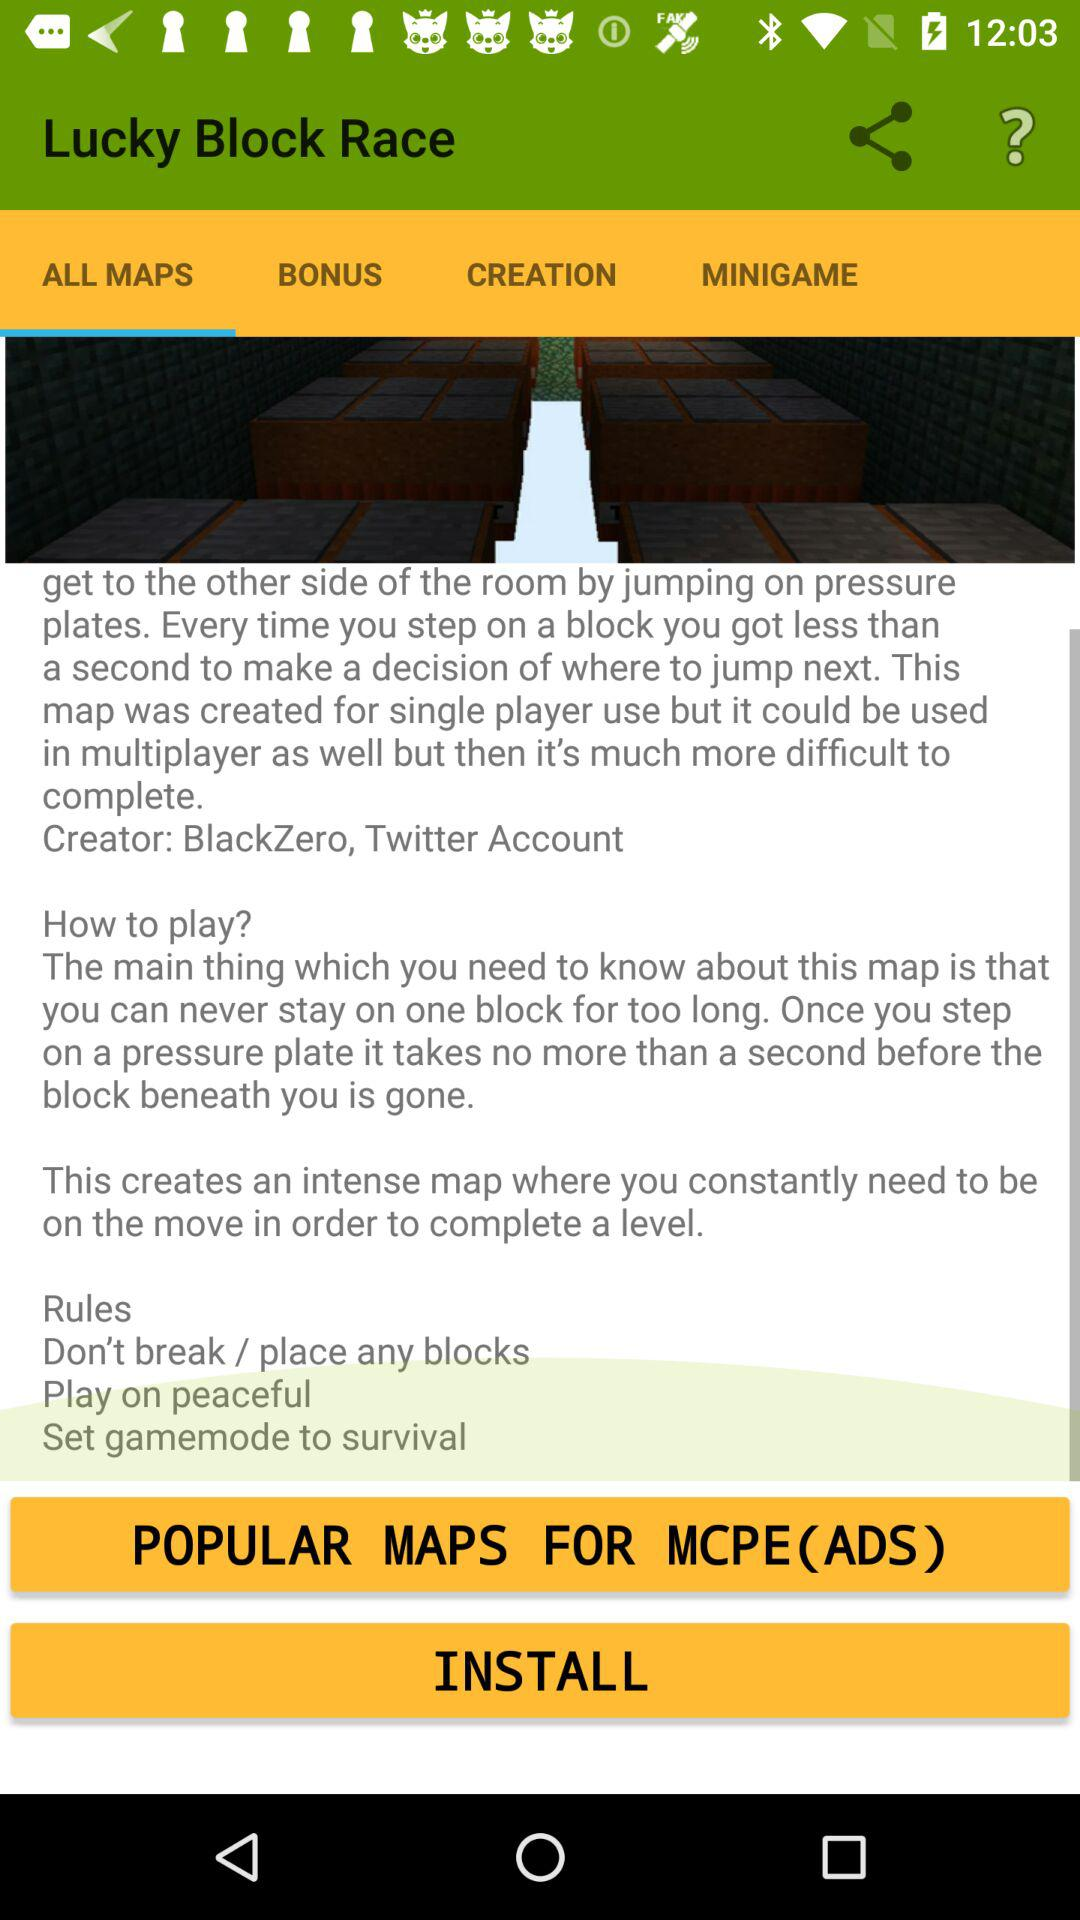What's the name of the creator? The name of the creator is "BlackZero". 